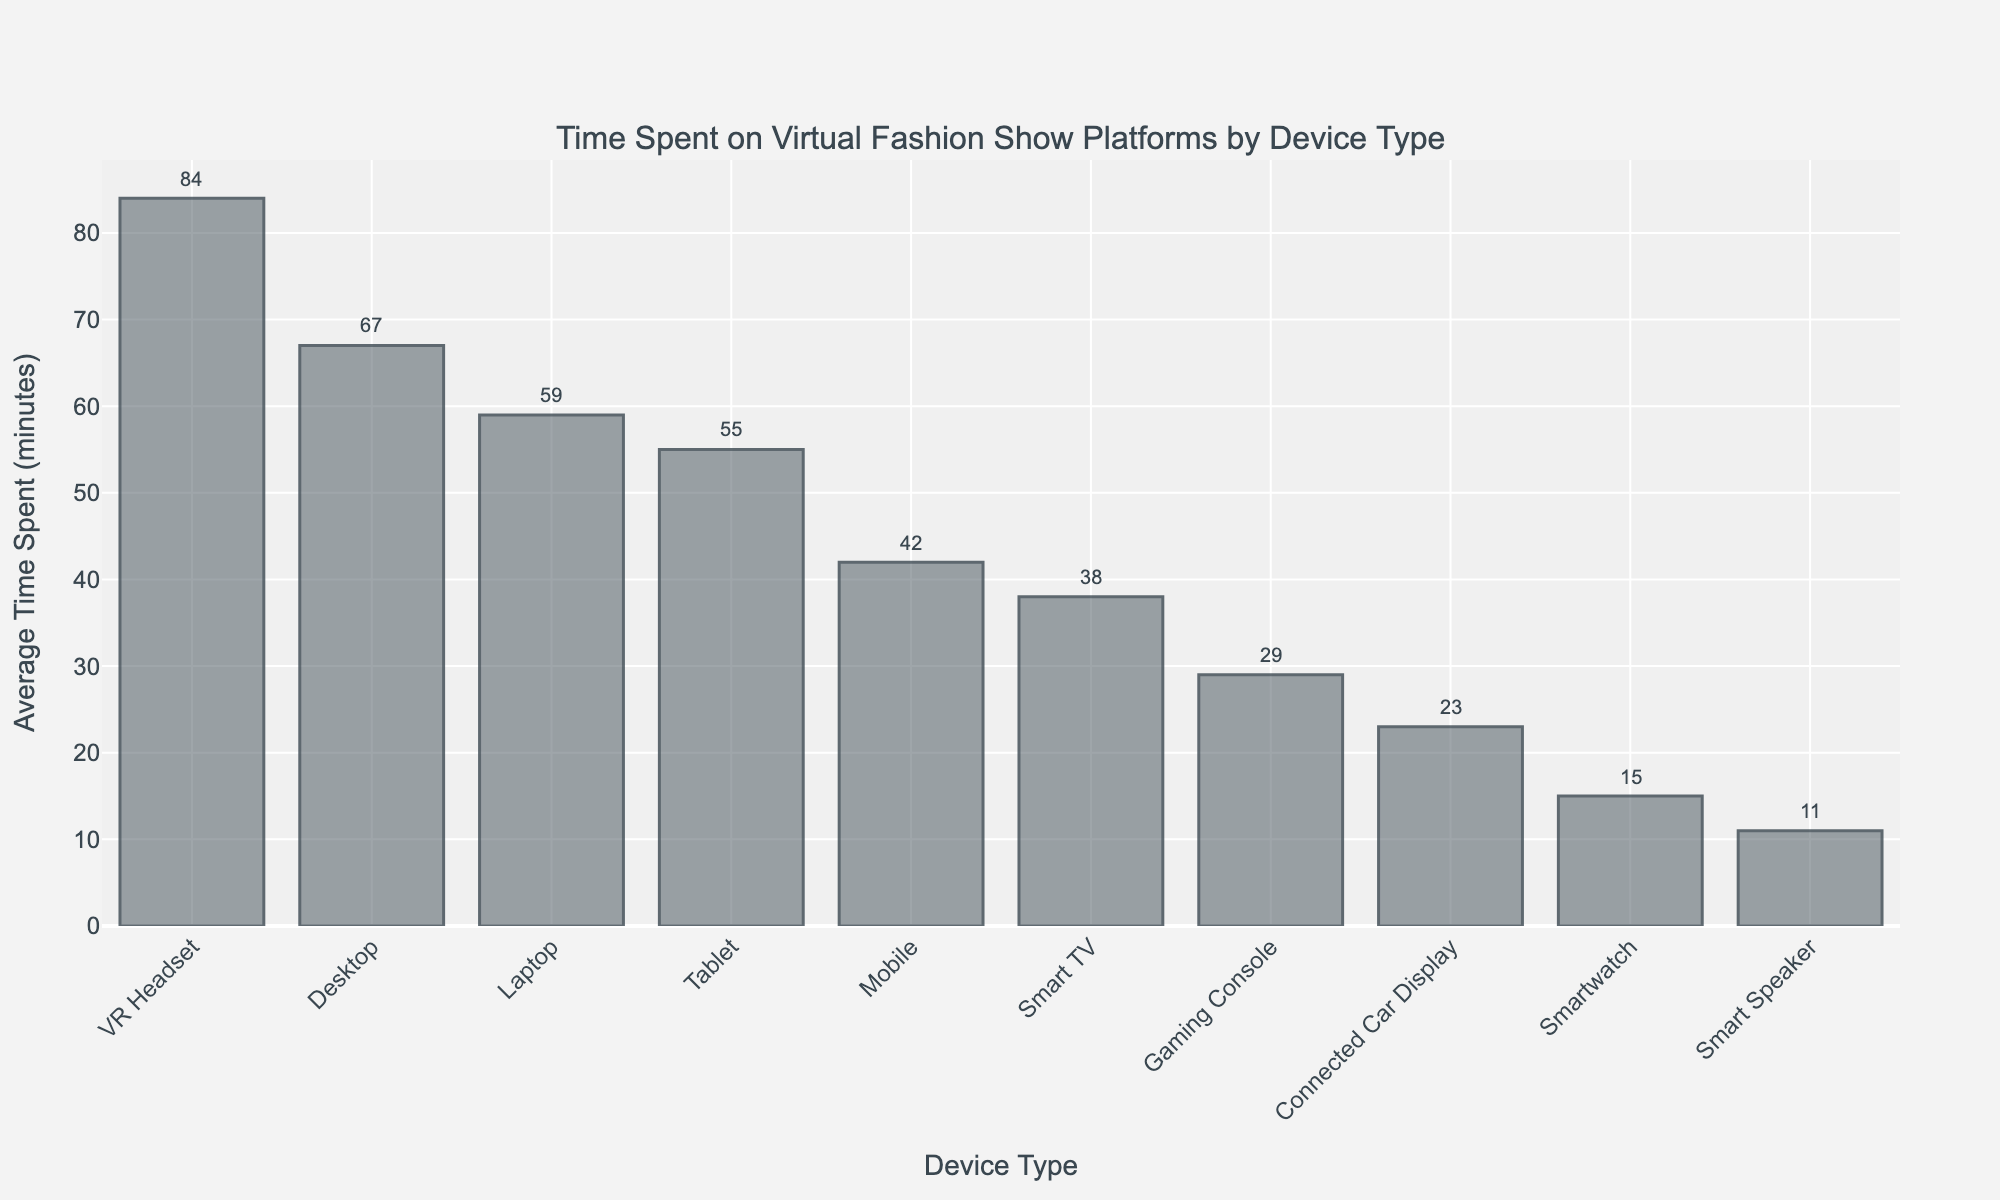What device type had the highest average time spent on virtual fashion show platforms? The tallest bar in the chart represents the device type with the highest average time spent. The label on the x-axis for this bar is "VR Headset."
Answer: VR Headset What is the difference in average time spent between the device with the highest time and the device with the lowest time? The highest average time spent is 84 minutes for VR Headset, and the lowest is 11 minutes for Smart Speaker. The difference is 84 - 11 = 73 minutes.
Answer: 73 minutes Which device type has a higher average time spent, Desktop or Laptop? Compare the heights of the bars for Desktop and Laptop. Desktop has an average time spent of 67 minutes, and Laptop has 59 minutes. Desktop has a higher average.
Answer: Desktop What is the sum of the average time spent on Mobile, Smartwatch, and Connected Car Display? Add the average times: Mobile (42) + Smartwatch (15) + Connected Car Display (23) = 42 + 15 + 23 = 80 minutes.
Answer: 80 minutes How many device types have an average time spent greater than 50 minutes? Identify and count the bars with heights over 50 minutes. They are "Desktop," "Tablet," "VR Headset," and "Laptop." There are 4 device types.
Answer: 4 What is the average time spent on devices excluding the top three highest time spent? Sum the average times of all devices excluding the top three (VR Headset, Desktop, Laptop): 42 + 55 + 38 + 29 + 15 + 11 + 23 = 213 minutes. Divide by the number of devices (8): 213 / 8 ≈ 26.625 minutes.
Answer: 26.625 minutes Is the average time spent on Smart TV greater than that on Gaming Console? Compare the heights of the bars for Smart TV (38 minutes) and Gaming Console (29 minutes). Smart TV has a greater average time.
Answer: Yes What is the median value of average time spent across all device types? List the values in ascending order: 11, 15, 23, 29, 38, 42, 55, 59, 67, 84. The median is the average of the 5th and 6th values (38 + 42) / 2 = 40 minutes.
Answer: 40 minutes By how much does the average time spent on a Tablet exceed that on a Mobile? Tablet has an average time of 55 minutes, and Mobile has 42 minutes. The difference is 55 - 42 = 13 minutes.
Answer: 13 minutes 